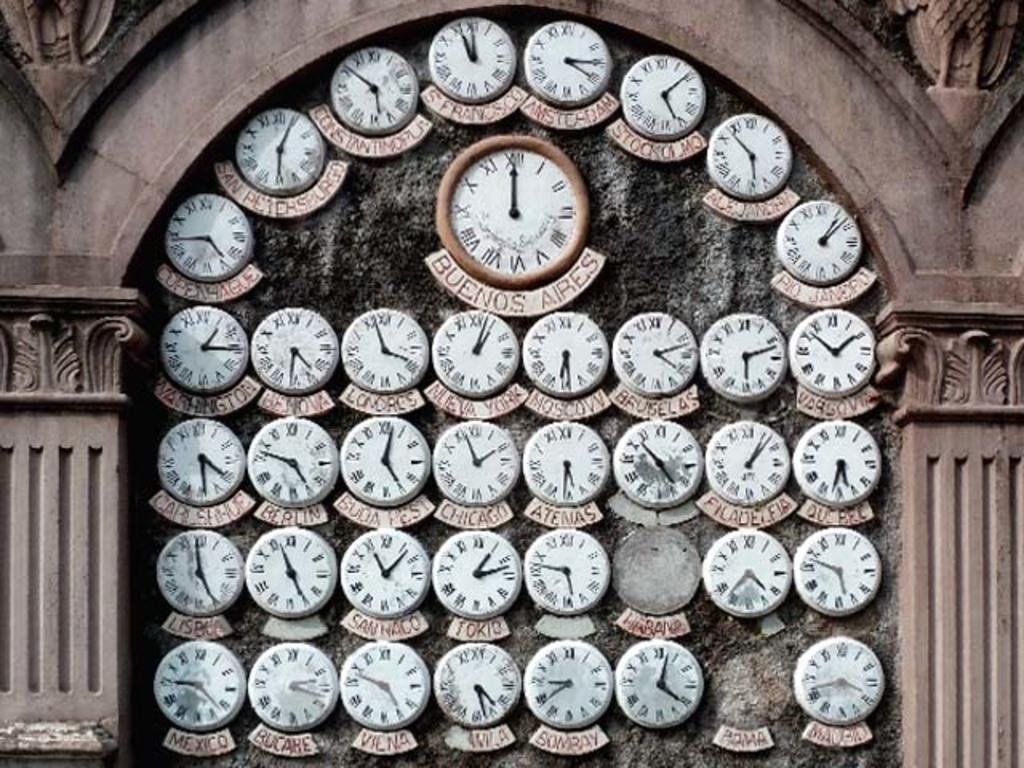What time is mentioned in the middle, for what city?
Give a very brief answer. Buenos aires. Is this picture taken from buenos aires?
Provide a succinct answer. Yes. 